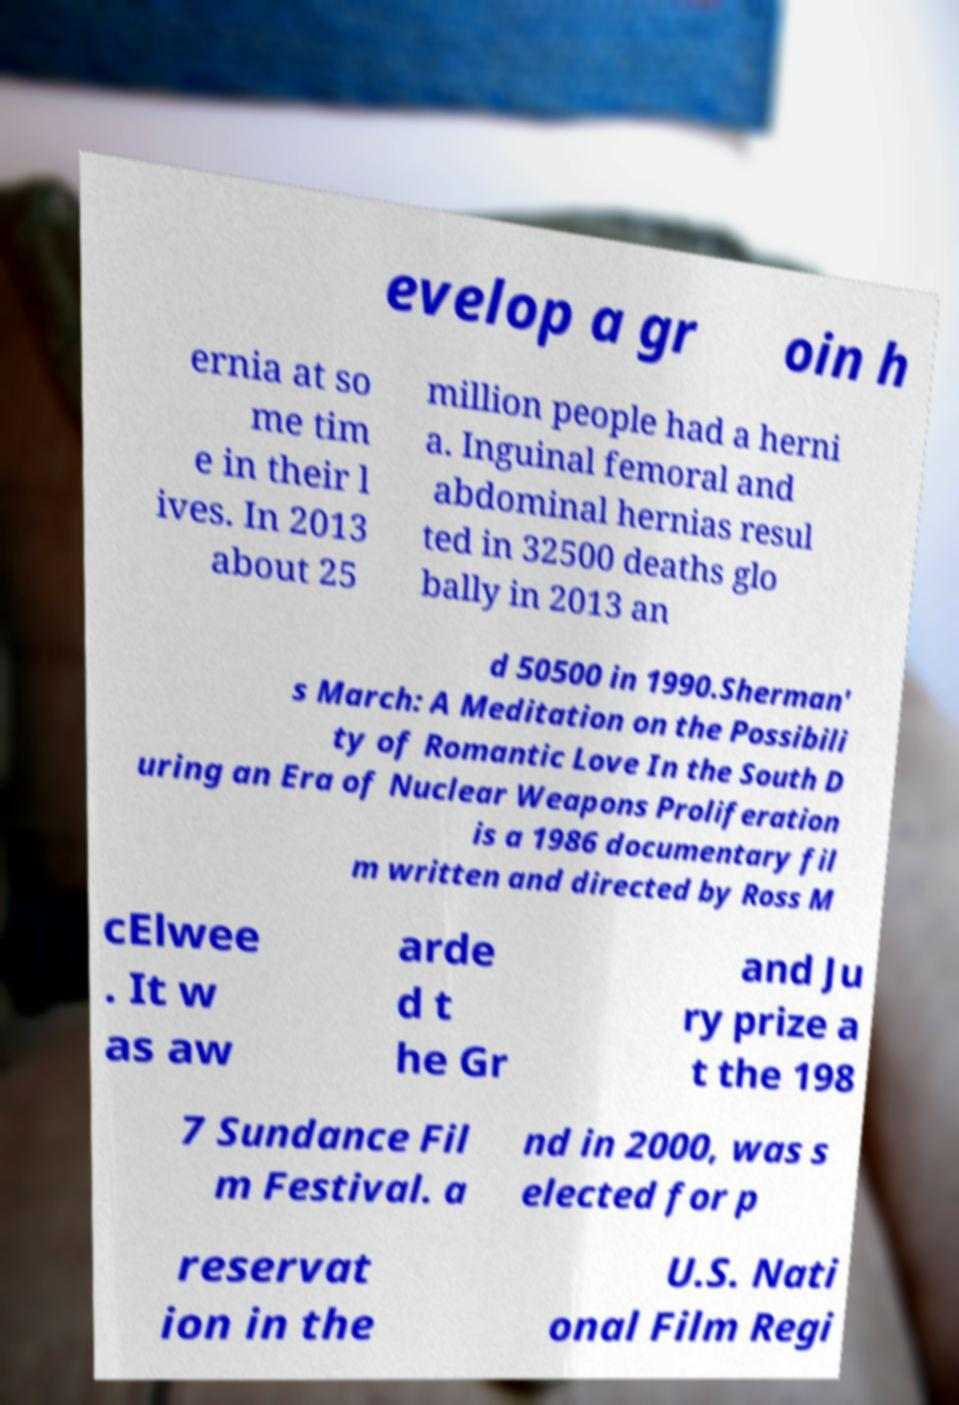Could you extract and type out the text from this image? evelop a gr oin h ernia at so me tim e in their l ives. In 2013 about 25 million people had a herni a. Inguinal femoral and abdominal hernias resul ted in 32500 deaths glo bally in 2013 an d 50500 in 1990.Sherman' s March: A Meditation on the Possibili ty of Romantic Love In the South D uring an Era of Nuclear Weapons Proliferation is a 1986 documentary fil m written and directed by Ross M cElwee . It w as aw arde d t he Gr and Ju ry prize a t the 198 7 Sundance Fil m Festival. a nd in 2000, was s elected for p reservat ion in the U.S. Nati onal Film Regi 